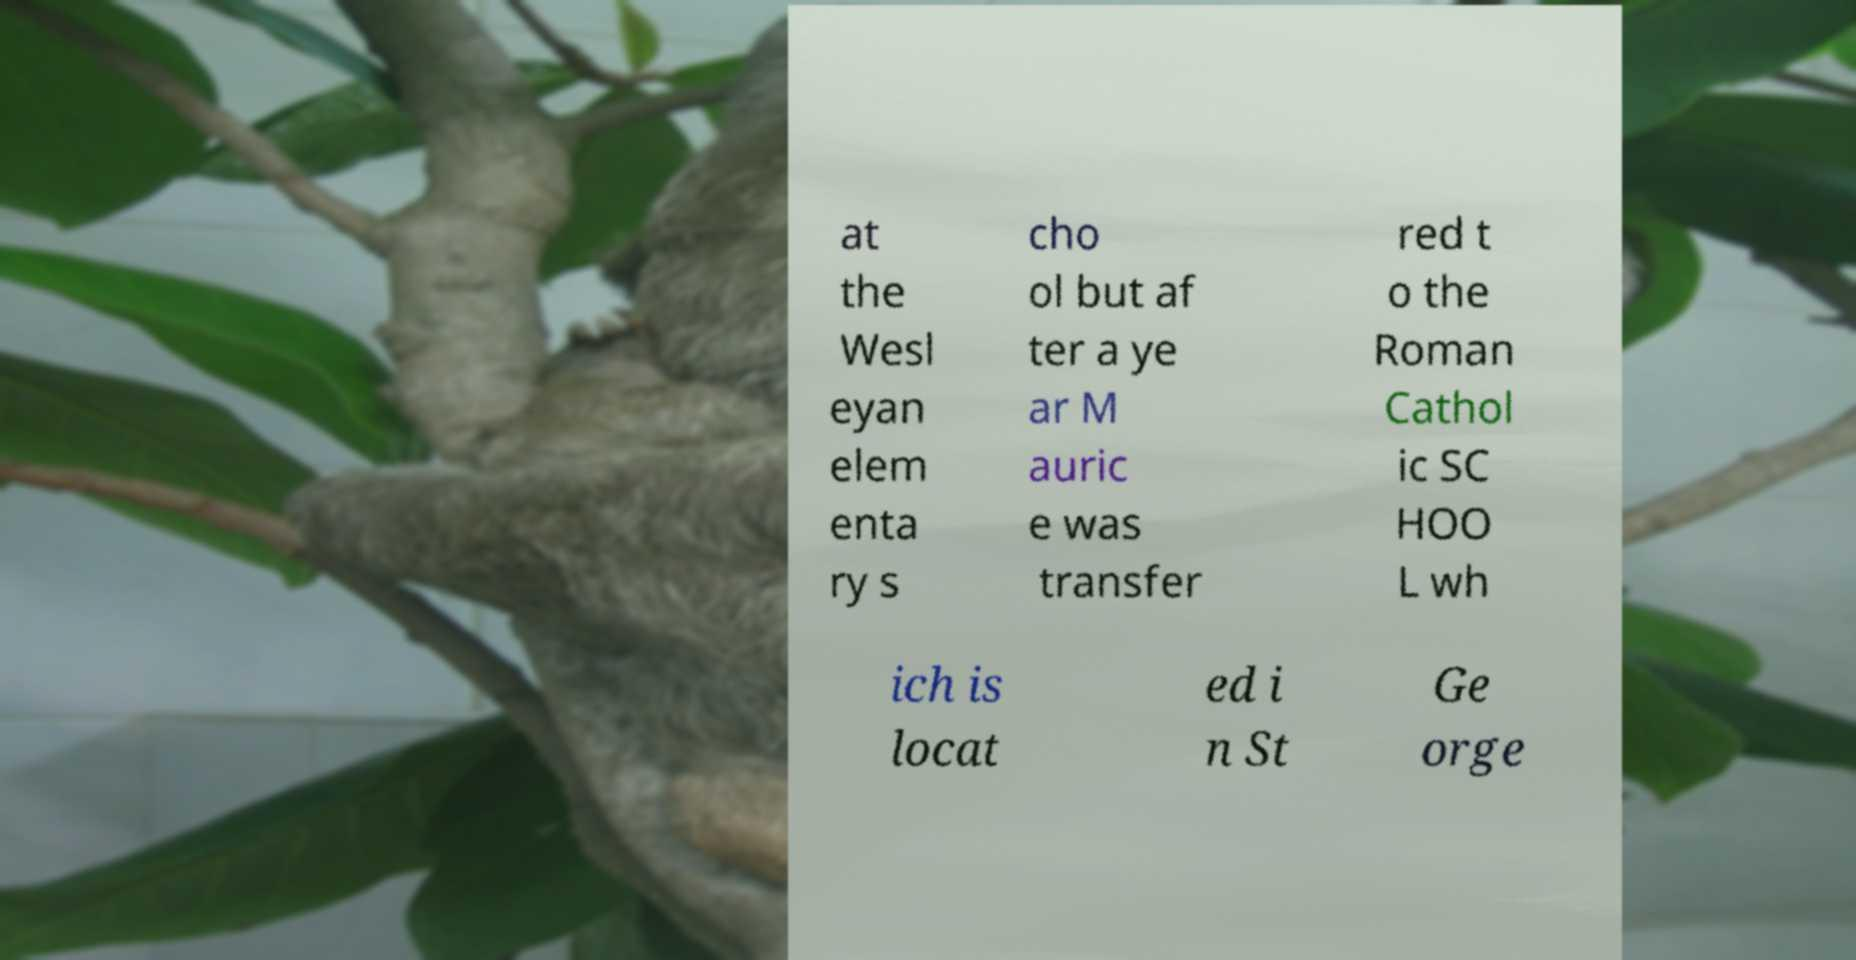I need the written content from this picture converted into text. Can you do that? at the Wesl eyan elem enta ry s cho ol but af ter a ye ar M auric e was transfer red t o the Roman Cathol ic SC HOO L wh ich is locat ed i n St Ge orge 